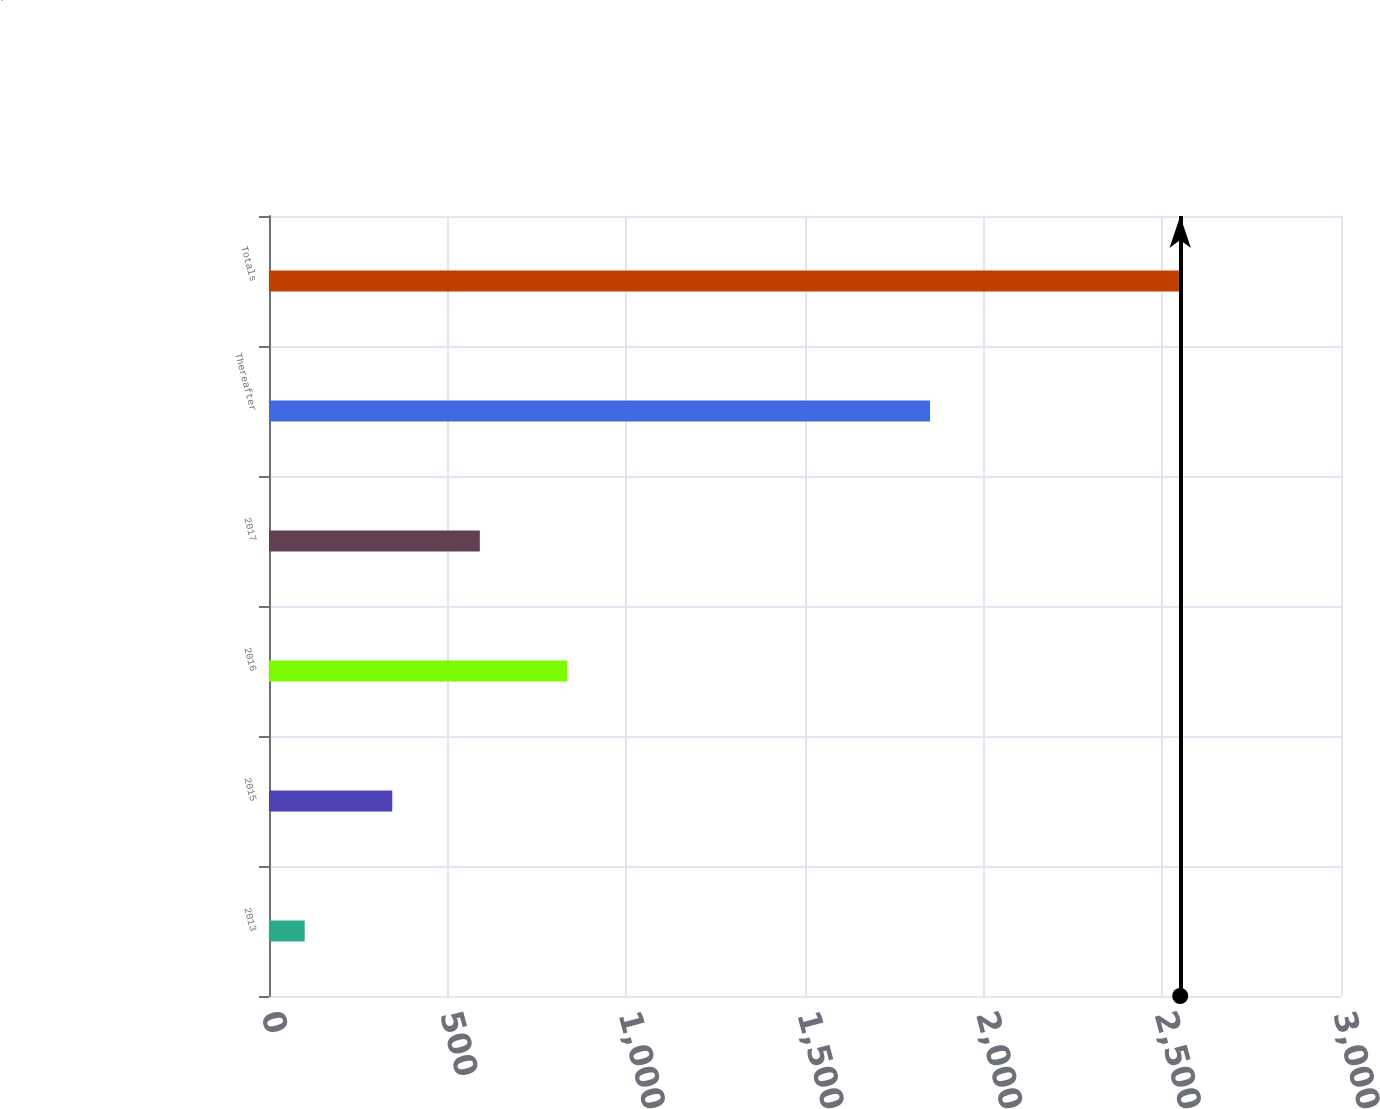<chart> <loc_0><loc_0><loc_500><loc_500><bar_chart><fcel>2013<fcel>2015<fcel>2016<fcel>2017<fcel>Thereafter<fcel>Totals<nl><fcel>100<fcel>345<fcel>835<fcel>590<fcel>1850<fcel>2550<nl></chart> 